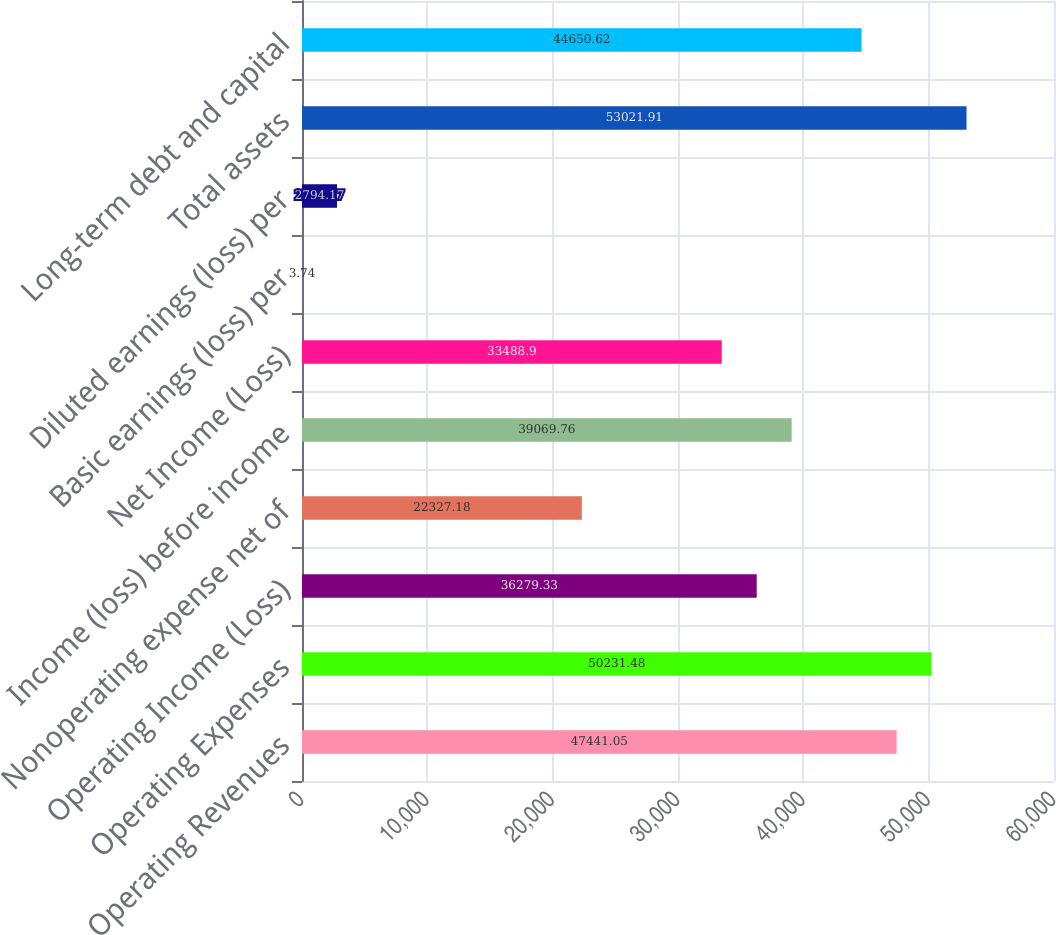<chart> <loc_0><loc_0><loc_500><loc_500><bar_chart><fcel>Operating Revenues<fcel>Operating Expenses<fcel>Operating Income (Loss)<fcel>Nonoperating expense net of<fcel>Income (loss) before income<fcel>Net Income (Loss)<fcel>Basic earnings (loss) per<fcel>Diluted earnings (loss) per<fcel>Total assets<fcel>Long-term debt and capital<nl><fcel>47441.1<fcel>50231.5<fcel>36279.3<fcel>22327.2<fcel>39069.8<fcel>33488.9<fcel>3.74<fcel>2794.17<fcel>53021.9<fcel>44650.6<nl></chart> 